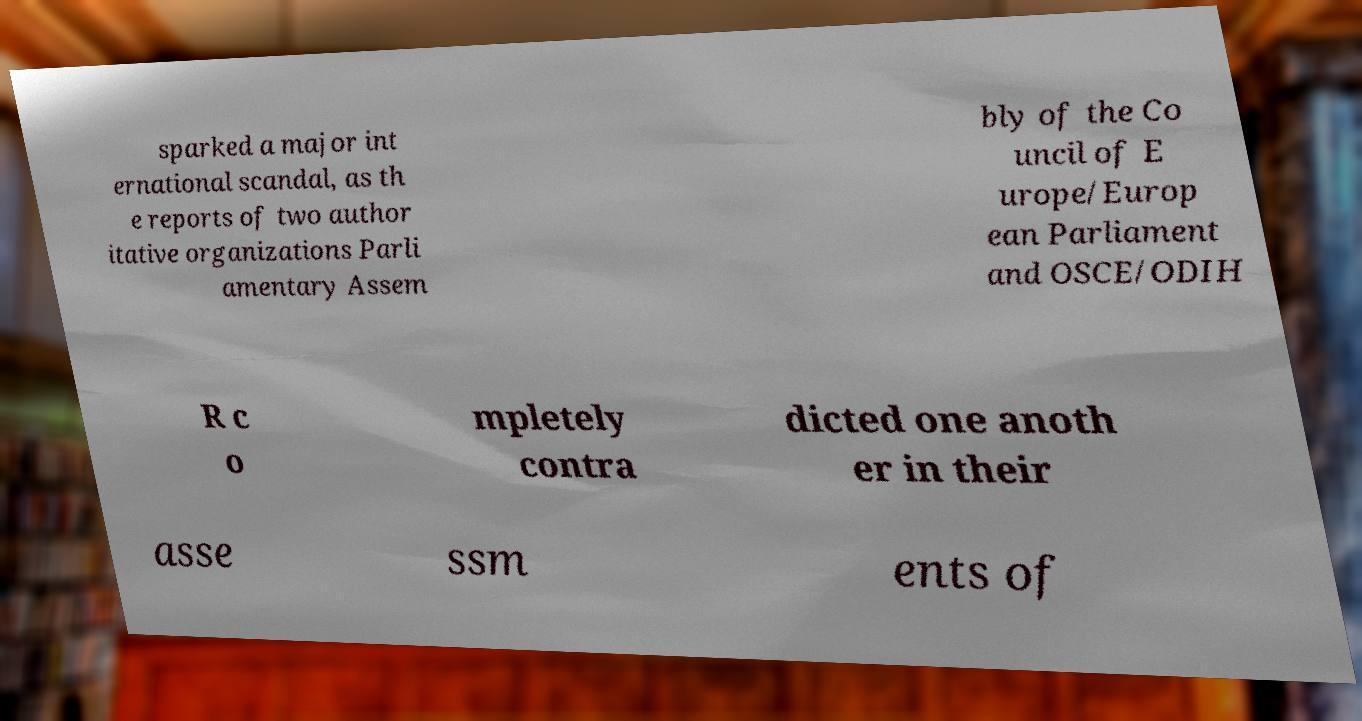Can you read and provide the text displayed in the image?This photo seems to have some interesting text. Can you extract and type it out for me? sparked a major int ernational scandal, as th e reports of two author itative organizations Parli amentary Assem bly of the Co uncil of E urope/Europ ean Parliament and OSCE/ODIH R c o mpletely contra dicted one anoth er in their asse ssm ents of 